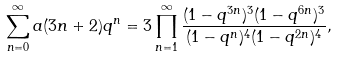<formula> <loc_0><loc_0><loc_500><loc_500>\sum _ { n = 0 } ^ { \infty } a ( 3 n + 2 ) q ^ { n } = 3 \prod _ { n = 1 } ^ { \infty } \frac { ( 1 - q ^ { 3 n } ) ^ { 3 } ( 1 - q ^ { 6 n } ) ^ { 3 } } { ( 1 - q ^ { n } ) ^ { 4 } ( 1 - q ^ { 2 n } ) ^ { 4 } } ,</formula> 